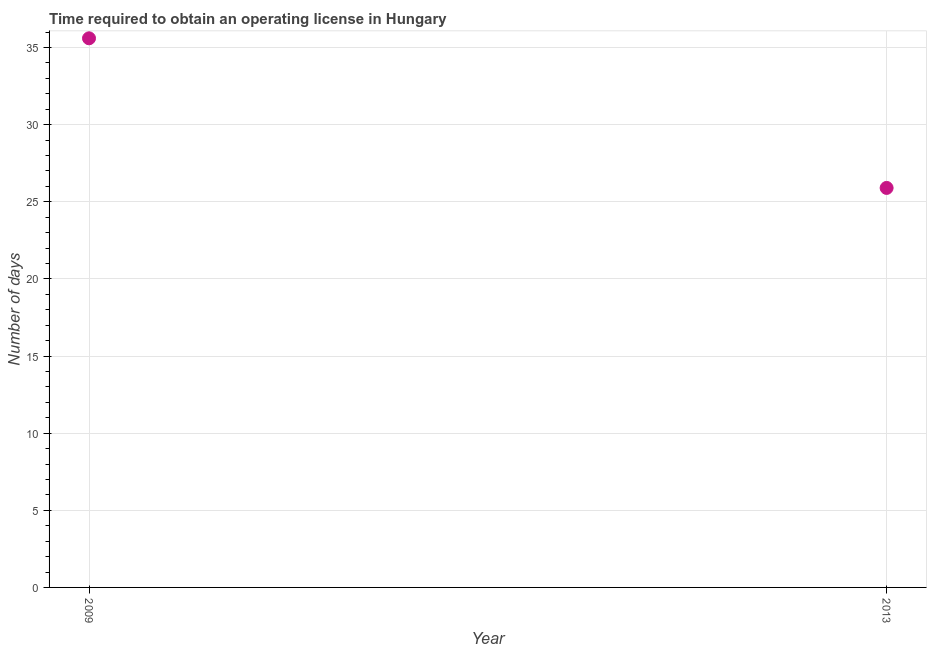What is the number of days to obtain operating license in 2009?
Make the answer very short. 35.6. Across all years, what is the maximum number of days to obtain operating license?
Provide a short and direct response. 35.6. Across all years, what is the minimum number of days to obtain operating license?
Your response must be concise. 25.9. What is the sum of the number of days to obtain operating license?
Your answer should be very brief. 61.5. What is the difference between the number of days to obtain operating license in 2009 and 2013?
Offer a very short reply. 9.7. What is the average number of days to obtain operating license per year?
Your response must be concise. 30.75. What is the median number of days to obtain operating license?
Give a very brief answer. 30.75. In how many years, is the number of days to obtain operating license greater than 14 days?
Keep it short and to the point. 2. Do a majority of the years between 2009 and 2013 (inclusive) have number of days to obtain operating license greater than 2 days?
Ensure brevity in your answer.  Yes. What is the ratio of the number of days to obtain operating license in 2009 to that in 2013?
Your answer should be very brief. 1.37. How many years are there in the graph?
Provide a succinct answer. 2. What is the difference between two consecutive major ticks on the Y-axis?
Offer a terse response. 5. What is the title of the graph?
Offer a terse response. Time required to obtain an operating license in Hungary. What is the label or title of the X-axis?
Provide a succinct answer. Year. What is the label or title of the Y-axis?
Make the answer very short. Number of days. What is the Number of days in 2009?
Provide a succinct answer. 35.6. What is the Number of days in 2013?
Keep it short and to the point. 25.9. What is the ratio of the Number of days in 2009 to that in 2013?
Keep it short and to the point. 1.38. 